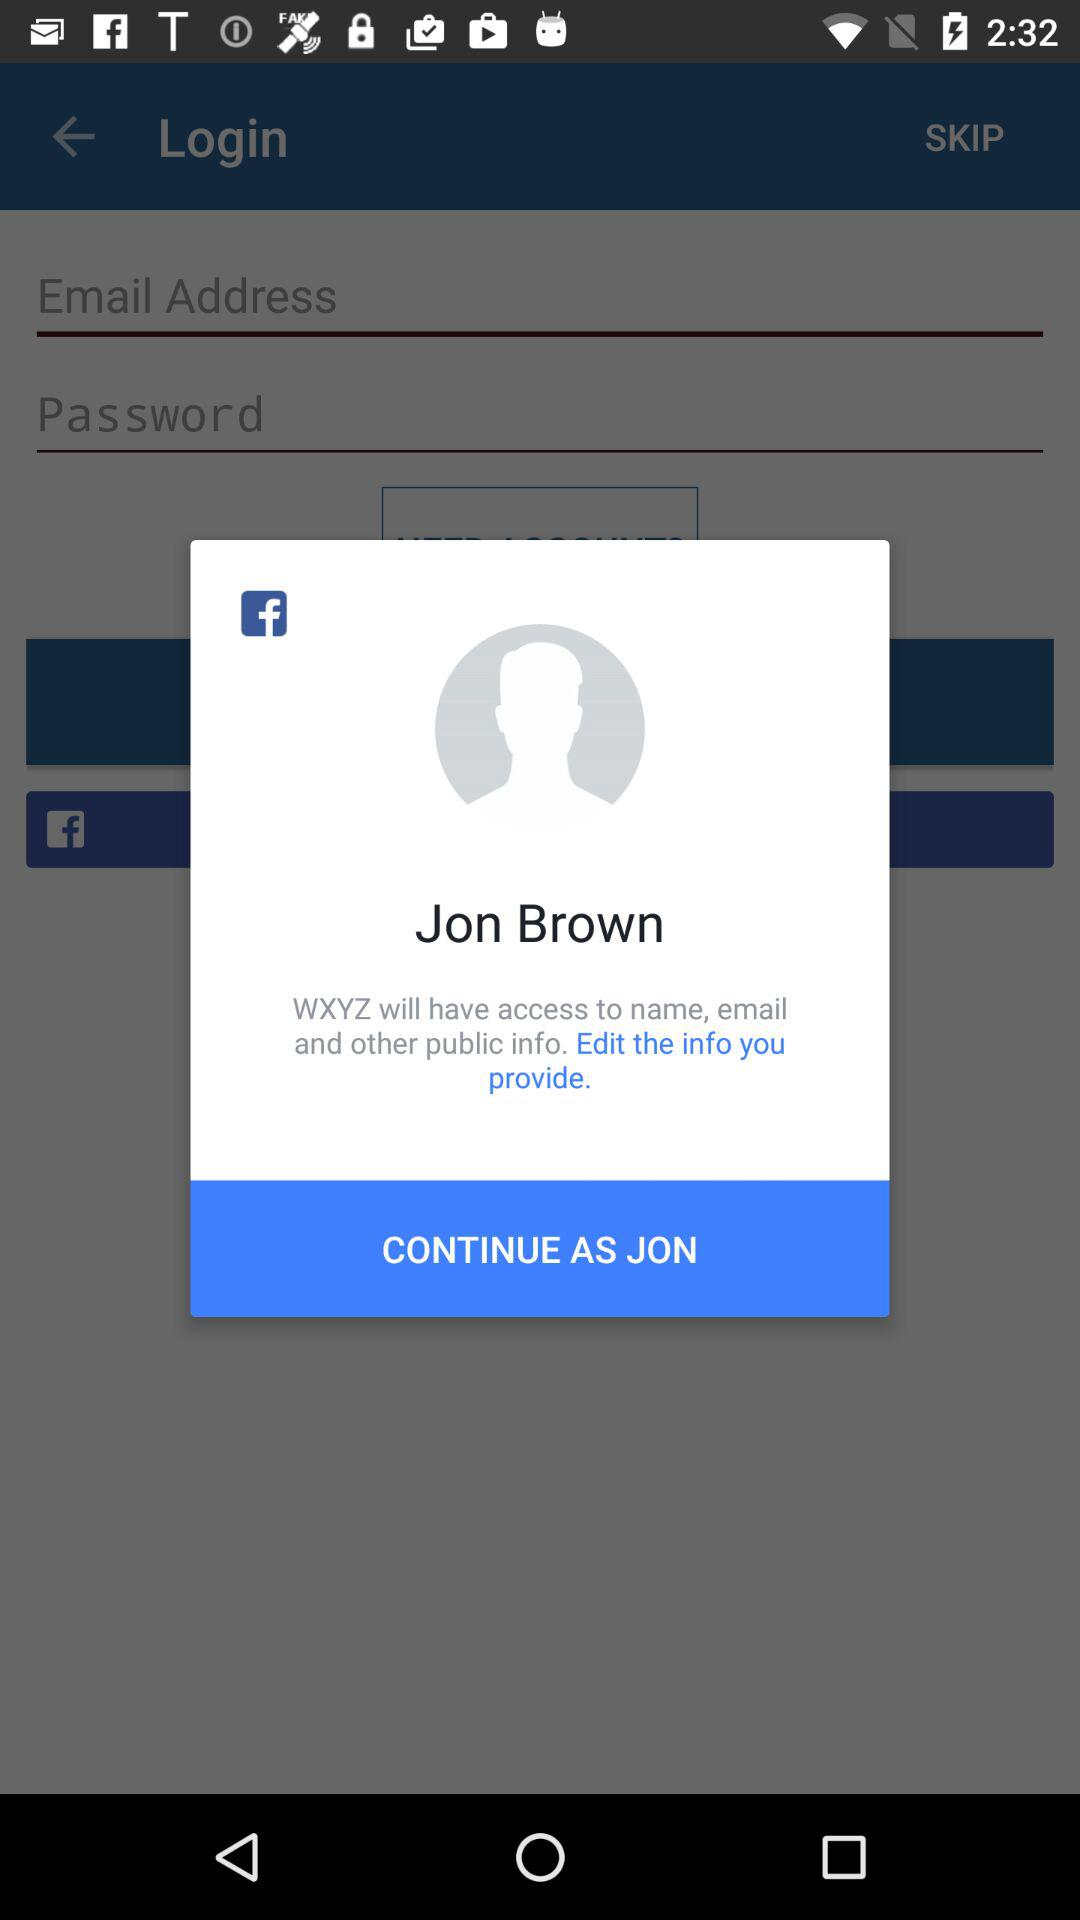What application will access the name, email and other public information? The application is "WXYZ". 